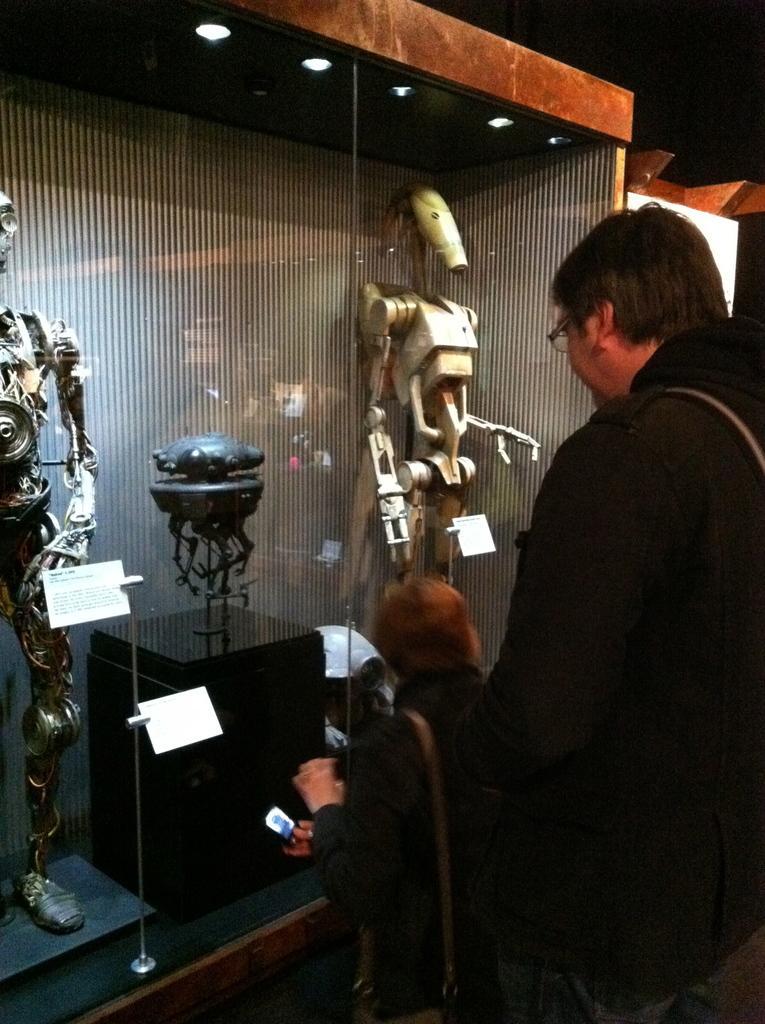How would you summarize this image in a sentence or two? In this image I can see a man is standing. Here I can see robots and some other objects. I can also see lights and a glass wall. 